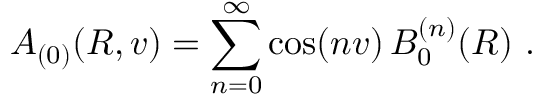<formula> <loc_0><loc_0><loc_500><loc_500>A _ { ( 0 ) } ( R , v ) = \sum _ { n = 0 } ^ { \infty } \cos ( n v ) \, B _ { 0 } ^ { ( n ) } ( R ) \ .</formula> 